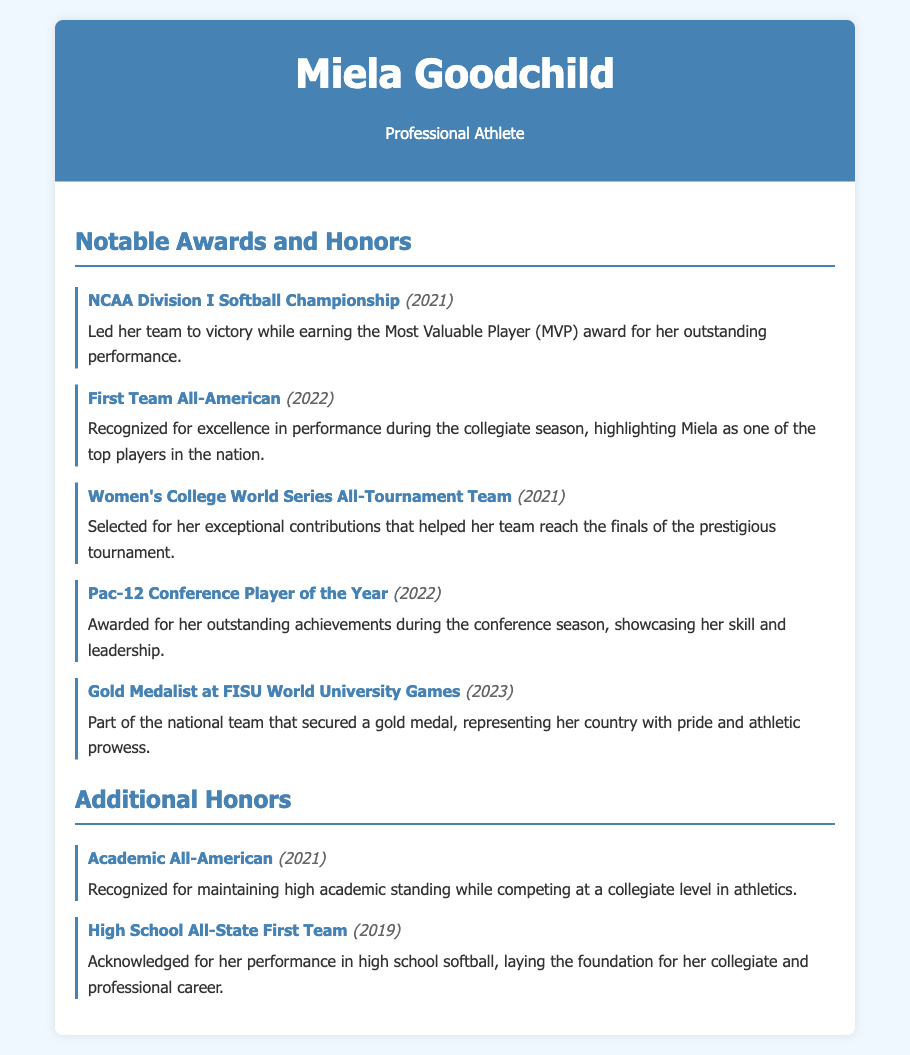What award did Miela Goodchild win in 2021? Miela Goodchild won the NCAA Division I Softball Championship in 2021.
Answer: NCAA Division I Softball Championship What year did Miela receive the First Team All-American honor? The First Team All-American honor was awarded to Miela in 2022.
Answer: 2022 How many awards did Miela win in 2021? Miela won two notable awards in 2021: NCAA Division I Softball Championship and Women's College World Series All-Tournament Team.
Answer: 2 Which award did Miela receive in 2023? Miela Goodchild received the Gold Medalist at FISU World University Games in 2023.
Answer: Gold Medalist at FISU World University Games What is one of the notable recognitions Miela achieved while in high school? The recognition she achieved while in high school is the High School All-State First Team in 2019.
Answer: High School All-State First Team What major recognition did Miela earn in the Pac-12 Conference? Miela earned the Pac-12 Conference Player of the Year award.
Answer: Pac-12 Conference Player of the Year How many total notable awards and honors are listed in the document? There are a total of seven notable awards and honors listed in the document.
Answer: 7 What does the Academic All-American award recognize? The Academic All-American award recognizes maintaining high academic standing while competing in athletics.
Answer: High academic standing 